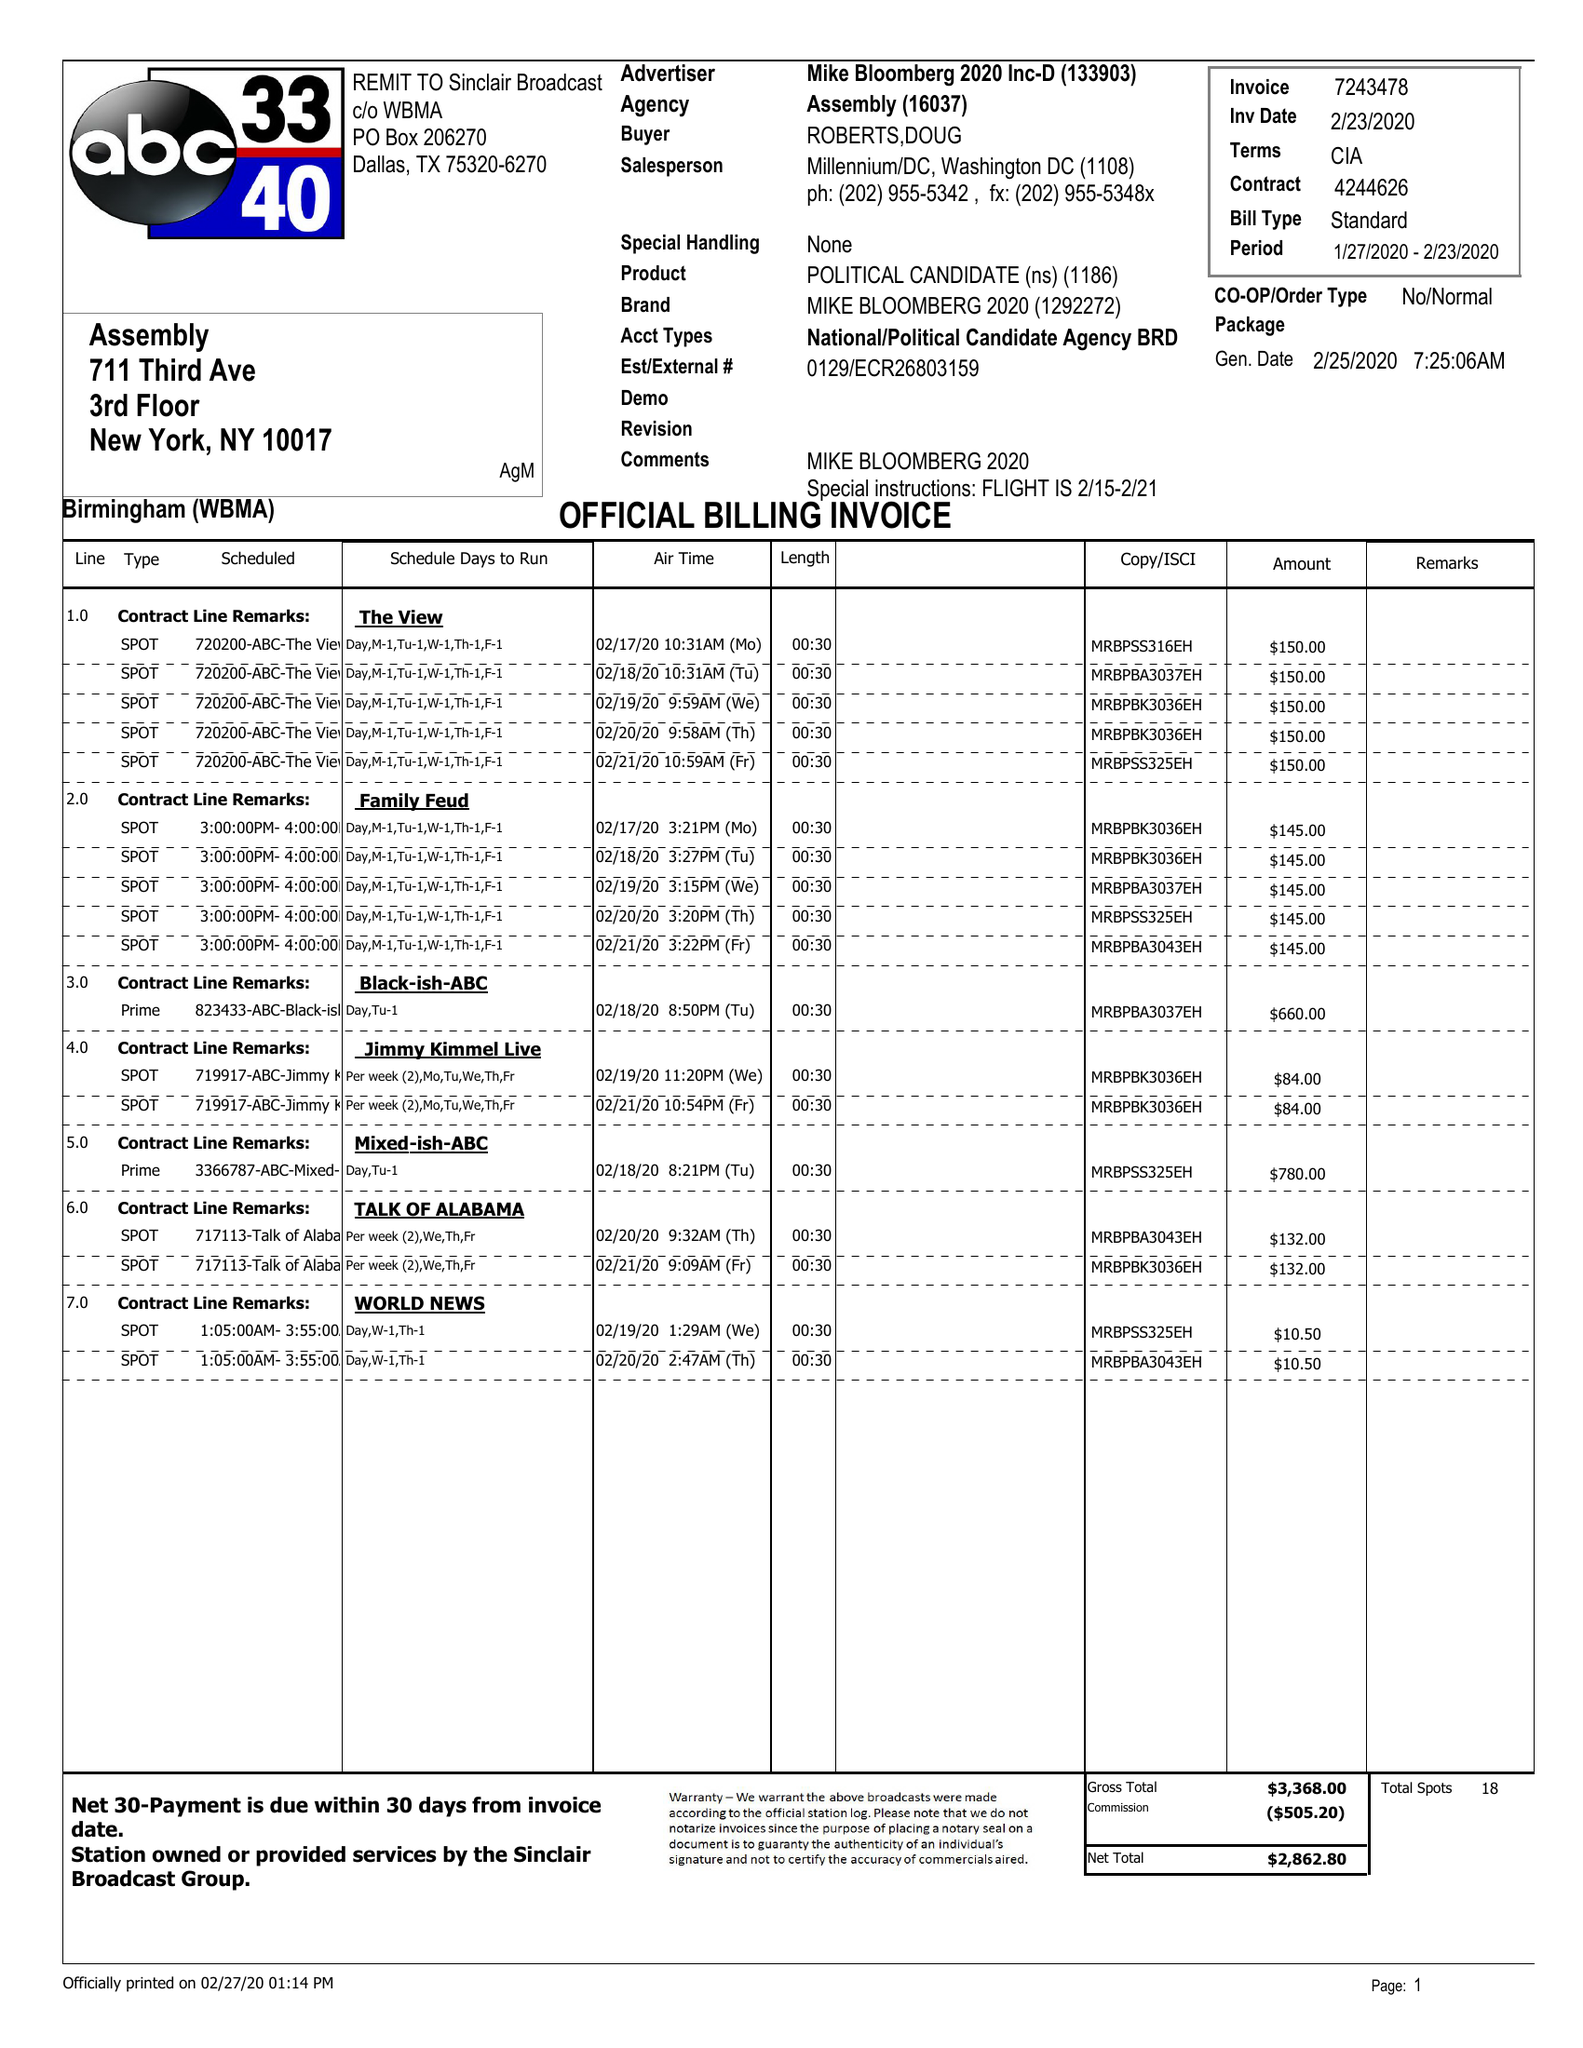What is the value for the contract_num?
Answer the question using a single word or phrase. 4244626 